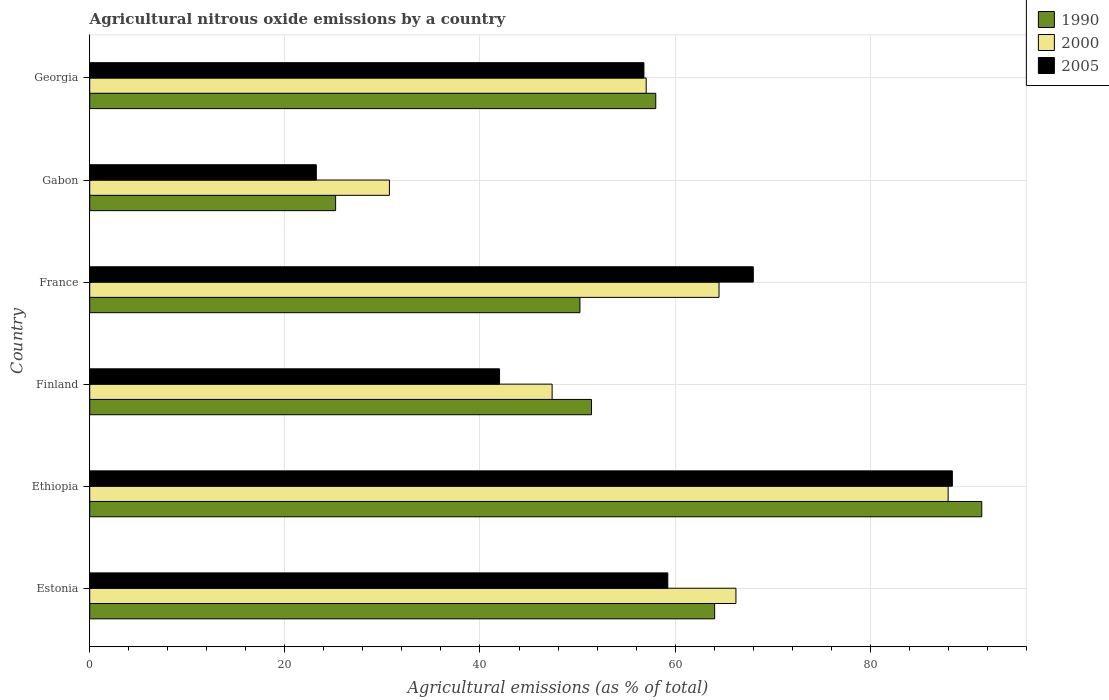How many different coloured bars are there?
Offer a terse response. 3. Are the number of bars per tick equal to the number of legend labels?
Provide a succinct answer. Yes. Are the number of bars on each tick of the Y-axis equal?
Ensure brevity in your answer.  Yes. What is the label of the 6th group of bars from the top?
Keep it short and to the point. Estonia. What is the amount of agricultural nitrous oxide emitted in 1990 in Georgia?
Offer a terse response. 58.02. Across all countries, what is the maximum amount of agricultural nitrous oxide emitted in 2000?
Your answer should be compact. 87.99. Across all countries, what is the minimum amount of agricultural nitrous oxide emitted in 2000?
Your answer should be compact. 30.72. In which country was the amount of agricultural nitrous oxide emitted in 1990 maximum?
Make the answer very short. Ethiopia. In which country was the amount of agricultural nitrous oxide emitted in 1990 minimum?
Provide a succinct answer. Gabon. What is the total amount of agricultural nitrous oxide emitted in 2000 in the graph?
Provide a short and direct response. 353.88. What is the difference between the amount of agricultural nitrous oxide emitted in 1990 in Estonia and that in Gabon?
Offer a terse response. 38.85. What is the difference between the amount of agricultural nitrous oxide emitted in 2005 in Finland and the amount of agricultural nitrous oxide emitted in 2000 in France?
Give a very brief answer. -22.5. What is the average amount of agricultural nitrous oxide emitted in 1990 per country?
Ensure brevity in your answer.  56.73. What is the difference between the amount of agricultural nitrous oxide emitted in 1990 and amount of agricultural nitrous oxide emitted in 2005 in Georgia?
Keep it short and to the point. 1.21. In how many countries, is the amount of agricultural nitrous oxide emitted in 1990 greater than 60 %?
Make the answer very short. 2. What is the ratio of the amount of agricultural nitrous oxide emitted in 2000 in Finland to that in France?
Ensure brevity in your answer.  0.73. Is the amount of agricultural nitrous oxide emitted in 1990 in Gabon less than that in Georgia?
Your answer should be compact. Yes. What is the difference between the highest and the second highest amount of agricultural nitrous oxide emitted in 1990?
Provide a short and direct response. 27.38. What is the difference between the highest and the lowest amount of agricultural nitrous oxide emitted in 2005?
Ensure brevity in your answer.  65.19. In how many countries, is the amount of agricultural nitrous oxide emitted in 1990 greater than the average amount of agricultural nitrous oxide emitted in 1990 taken over all countries?
Offer a terse response. 3. What does the 1st bar from the bottom in France represents?
Ensure brevity in your answer.  1990. How many countries are there in the graph?
Provide a short and direct response. 6. Are the values on the major ticks of X-axis written in scientific E-notation?
Your response must be concise. No. Does the graph contain grids?
Make the answer very short. Yes. How many legend labels are there?
Give a very brief answer. 3. What is the title of the graph?
Your answer should be very brief. Agricultural nitrous oxide emissions by a country. What is the label or title of the X-axis?
Offer a very short reply. Agricultural emissions (as % of total). What is the Agricultural emissions (as % of total) of 1990 in Estonia?
Your response must be concise. 64.06. What is the Agricultural emissions (as % of total) in 2000 in Estonia?
Your response must be concise. 66.24. What is the Agricultural emissions (as % of total) in 2005 in Estonia?
Keep it short and to the point. 59.25. What is the Agricultural emissions (as % of total) in 1990 in Ethiopia?
Keep it short and to the point. 91.43. What is the Agricultural emissions (as % of total) of 2000 in Ethiopia?
Your answer should be very brief. 87.99. What is the Agricultural emissions (as % of total) in 2005 in Ethiopia?
Your response must be concise. 88.42. What is the Agricultural emissions (as % of total) of 1990 in Finland?
Offer a very short reply. 51.43. What is the Agricultural emissions (as % of total) in 2000 in Finland?
Your answer should be very brief. 47.4. What is the Agricultural emissions (as % of total) of 2005 in Finland?
Your answer should be very brief. 42.01. What is the Agricultural emissions (as % of total) in 1990 in France?
Provide a succinct answer. 50.25. What is the Agricultural emissions (as % of total) of 2000 in France?
Offer a terse response. 64.5. What is the Agricultural emissions (as % of total) in 2005 in France?
Provide a short and direct response. 68.02. What is the Agricultural emissions (as % of total) in 1990 in Gabon?
Provide a succinct answer. 25.2. What is the Agricultural emissions (as % of total) of 2000 in Gabon?
Your answer should be very brief. 30.72. What is the Agricultural emissions (as % of total) in 2005 in Gabon?
Offer a very short reply. 23.22. What is the Agricultural emissions (as % of total) of 1990 in Georgia?
Make the answer very short. 58.02. What is the Agricultural emissions (as % of total) of 2000 in Georgia?
Your answer should be very brief. 57.04. What is the Agricultural emissions (as % of total) in 2005 in Georgia?
Ensure brevity in your answer.  56.81. Across all countries, what is the maximum Agricultural emissions (as % of total) in 1990?
Provide a short and direct response. 91.43. Across all countries, what is the maximum Agricultural emissions (as % of total) in 2000?
Your response must be concise. 87.99. Across all countries, what is the maximum Agricultural emissions (as % of total) of 2005?
Your response must be concise. 88.42. Across all countries, what is the minimum Agricultural emissions (as % of total) of 1990?
Offer a very short reply. 25.2. Across all countries, what is the minimum Agricultural emissions (as % of total) of 2000?
Ensure brevity in your answer.  30.72. Across all countries, what is the minimum Agricultural emissions (as % of total) in 2005?
Keep it short and to the point. 23.22. What is the total Agricultural emissions (as % of total) of 1990 in the graph?
Provide a succinct answer. 340.39. What is the total Agricultural emissions (as % of total) of 2000 in the graph?
Provide a short and direct response. 353.88. What is the total Agricultural emissions (as % of total) of 2005 in the graph?
Your answer should be compact. 337.72. What is the difference between the Agricultural emissions (as % of total) in 1990 in Estonia and that in Ethiopia?
Ensure brevity in your answer.  -27.38. What is the difference between the Agricultural emissions (as % of total) of 2000 in Estonia and that in Ethiopia?
Ensure brevity in your answer.  -21.75. What is the difference between the Agricultural emissions (as % of total) of 2005 in Estonia and that in Ethiopia?
Your response must be concise. -29.17. What is the difference between the Agricultural emissions (as % of total) of 1990 in Estonia and that in Finland?
Provide a short and direct response. 12.62. What is the difference between the Agricultural emissions (as % of total) of 2000 in Estonia and that in Finland?
Provide a short and direct response. 18.84. What is the difference between the Agricultural emissions (as % of total) of 2005 in Estonia and that in Finland?
Provide a short and direct response. 17.25. What is the difference between the Agricultural emissions (as % of total) of 1990 in Estonia and that in France?
Ensure brevity in your answer.  13.81. What is the difference between the Agricultural emissions (as % of total) of 2000 in Estonia and that in France?
Your answer should be compact. 1.73. What is the difference between the Agricultural emissions (as % of total) in 2005 in Estonia and that in France?
Offer a very short reply. -8.76. What is the difference between the Agricultural emissions (as % of total) of 1990 in Estonia and that in Gabon?
Your answer should be compact. 38.85. What is the difference between the Agricultural emissions (as % of total) in 2000 in Estonia and that in Gabon?
Offer a very short reply. 35.52. What is the difference between the Agricultural emissions (as % of total) of 2005 in Estonia and that in Gabon?
Offer a very short reply. 36.03. What is the difference between the Agricultural emissions (as % of total) of 1990 in Estonia and that in Georgia?
Ensure brevity in your answer.  6.04. What is the difference between the Agricultural emissions (as % of total) of 2000 in Estonia and that in Georgia?
Your response must be concise. 9.2. What is the difference between the Agricultural emissions (as % of total) in 2005 in Estonia and that in Georgia?
Your response must be concise. 2.45. What is the difference between the Agricultural emissions (as % of total) in 1990 in Ethiopia and that in Finland?
Provide a succinct answer. 40. What is the difference between the Agricultural emissions (as % of total) in 2000 in Ethiopia and that in Finland?
Give a very brief answer. 40.59. What is the difference between the Agricultural emissions (as % of total) in 2005 in Ethiopia and that in Finland?
Your response must be concise. 46.41. What is the difference between the Agricultural emissions (as % of total) in 1990 in Ethiopia and that in France?
Make the answer very short. 41.19. What is the difference between the Agricultural emissions (as % of total) of 2000 in Ethiopia and that in France?
Your response must be concise. 23.48. What is the difference between the Agricultural emissions (as % of total) in 2005 in Ethiopia and that in France?
Your answer should be compact. 20.4. What is the difference between the Agricultural emissions (as % of total) of 1990 in Ethiopia and that in Gabon?
Your answer should be compact. 66.23. What is the difference between the Agricultural emissions (as % of total) of 2000 in Ethiopia and that in Gabon?
Provide a succinct answer. 57.27. What is the difference between the Agricultural emissions (as % of total) of 2005 in Ethiopia and that in Gabon?
Offer a terse response. 65.19. What is the difference between the Agricultural emissions (as % of total) in 1990 in Ethiopia and that in Georgia?
Your response must be concise. 33.41. What is the difference between the Agricultural emissions (as % of total) of 2000 in Ethiopia and that in Georgia?
Offer a terse response. 30.95. What is the difference between the Agricultural emissions (as % of total) of 2005 in Ethiopia and that in Georgia?
Offer a terse response. 31.61. What is the difference between the Agricultural emissions (as % of total) of 1990 in Finland and that in France?
Offer a very short reply. 1.19. What is the difference between the Agricultural emissions (as % of total) of 2000 in Finland and that in France?
Offer a very short reply. -17.11. What is the difference between the Agricultural emissions (as % of total) of 2005 in Finland and that in France?
Your response must be concise. -26.01. What is the difference between the Agricultural emissions (as % of total) of 1990 in Finland and that in Gabon?
Provide a short and direct response. 26.23. What is the difference between the Agricultural emissions (as % of total) in 2000 in Finland and that in Gabon?
Make the answer very short. 16.68. What is the difference between the Agricultural emissions (as % of total) in 2005 in Finland and that in Gabon?
Your answer should be compact. 18.78. What is the difference between the Agricultural emissions (as % of total) of 1990 in Finland and that in Georgia?
Your response must be concise. -6.59. What is the difference between the Agricultural emissions (as % of total) in 2000 in Finland and that in Georgia?
Your response must be concise. -9.64. What is the difference between the Agricultural emissions (as % of total) in 2005 in Finland and that in Georgia?
Offer a terse response. -14.8. What is the difference between the Agricultural emissions (as % of total) of 1990 in France and that in Gabon?
Provide a short and direct response. 25.04. What is the difference between the Agricultural emissions (as % of total) in 2000 in France and that in Gabon?
Give a very brief answer. 33.79. What is the difference between the Agricultural emissions (as % of total) of 2005 in France and that in Gabon?
Provide a short and direct response. 44.79. What is the difference between the Agricultural emissions (as % of total) of 1990 in France and that in Georgia?
Give a very brief answer. -7.77. What is the difference between the Agricultural emissions (as % of total) of 2000 in France and that in Georgia?
Provide a succinct answer. 7.47. What is the difference between the Agricultural emissions (as % of total) of 2005 in France and that in Georgia?
Your answer should be compact. 11.21. What is the difference between the Agricultural emissions (as % of total) in 1990 in Gabon and that in Georgia?
Keep it short and to the point. -32.82. What is the difference between the Agricultural emissions (as % of total) in 2000 in Gabon and that in Georgia?
Your answer should be very brief. -26.32. What is the difference between the Agricultural emissions (as % of total) of 2005 in Gabon and that in Georgia?
Make the answer very short. -33.58. What is the difference between the Agricultural emissions (as % of total) in 1990 in Estonia and the Agricultural emissions (as % of total) in 2000 in Ethiopia?
Ensure brevity in your answer.  -23.93. What is the difference between the Agricultural emissions (as % of total) in 1990 in Estonia and the Agricultural emissions (as % of total) in 2005 in Ethiopia?
Provide a short and direct response. -24.36. What is the difference between the Agricultural emissions (as % of total) in 2000 in Estonia and the Agricultural emissions (as % of total) in 2005 in Ethiopia?
Make the answer very short. -22.18. What is the difference between the Agricultural emissions (as % of total) of 1990 in Estonia and the Agricultural emissions (as % of total) of 2000 in Finland?
Provide a succinct answer. 16.66. What is the difference between the Agricultural emissions (as % of total) of 1990 in Estonia and the Agricultural emissions (as % of total) of 2005 in Finland?
Make the answer very short. 22.05. What is the difference between the Agricultural emissions (as % of total) of 2000 in Estonia and the Agricultural emissions (as % of total) of 2005 in Finland?
Offer a terse response. 24.23. What is the difference between the Agricultural emissions (as % of total) of 1990 in Estonia and the Agricultural emissions (as % of total) of 2000 in France?
Your answer should be compact. -0.45. What is the difference between the Agricultural emissions (as % of total) of 1990 in Estonia and the Agricultural emissions (as % of total) of 2005 in France?
Give a very brief answer. -3.96. What is the difference between the Agricultural emissions (as % of total) in 2000 in Estonia and the Agricultural emissions (as % of total) in 2005 in France?
Ensure brevity in your answer.  -1.78. What is the difference between the Agricultural emissions (as % of total) in 1990 in Estonia and the Agricultural emissions (as % of total) in 2000 in Gabon?
Make the answer very short. 33.34. What is the difference between the Agricultural emissions (as % of total) of 1990 in Estonia and the Agricultural emissions (as % of total) of 2005 in Gabon?
Provide a short and direct response. 40.83. What is the difference between the Agricultural emissions (as % of total) in 2000 in Estonia and the Agricultural emissions (as % of total) in 2005 in Gabon?
Provide a succinct answer. 43.01. What is the difference between the Agricultural emissions (as % of total) of 1990 in Estonia and the Agricultural emissions (as % of total) of 2000 in Georgia?
Keep it short and to the point. 7.02. What is the difference between the Agricultural emissions (as % of total) of 1990 in Estonia and the Agricultural emissions (as % of total) of 2005 in Georgia?
Provide a succinct answer. 7.25. What is the difference between the Agricultural emissions (as % of total) of 2000 in Estonia and the Agricultural emissions (as % of total) of 2005 in Georgia?
Provide a succinct answer. 9.43. What is the difference between the Agricultural emissions (as % of total) in 1990 in Ethiopia and the Agricultural emissions (as % of total) in 2000 in Finland?
Your answer should be very brief. 44.04. What is the difference between the Agricultural emissions (as % of total) of 1990 in Ethiopia and the Agricultural emissions (as % of total) of 2005 in Finland?
Offer a very short reply. 49.43. What is the difference between the Agricultural emissions (as % of total) of 2000 in Ethiopia and the Agricultural emissions (as % of total) of 2005 in Finland?
Your answer should be compact. 45.98. What is the difference between the Agricultural emissions (as % of total) of 1990 in Ethiopia and the Agricultural emissions (as % of total) of 2000 in France?
Offer a terse response. 26.93. What is the difference between the Agricultural emissions (as % of total) of 1990 in Ethiopia and the Agricultural emissions (as % of total) of 2005 in France?
Your response must be concise. 23.42. What is the difference between the Agricultural emissions (as % of total) in 2000 in Ethiopia and the Agricultural emissions (as % of total) in 2005 in France?
Keep it short and to the point. 19.97. What is the difference between the Agricultural emissions (as % of total) of 1990 in Ethiopia and the Agricultural emissions (as % of total) of 2000 in Gabon?
Ensure brevity in your answer.  60.72. What is the difference between the Agricultural emissions (as % of total) of 1990 in Ethiopia and the Agricultural emissions (as % of total) of 2005 in Gabon?
Make the answer very short. 68.21. What is the difference between the Agricultural emissions (as % of total) of 2000 in Ethiopia and the Agricultural emissions (as % of total) of 2005 in Gabon?
Keep it short and to the point. 64.76. What is the difference between the Agricultural emissions (as % of total) in 1990 in Ethiopia and the Agricultural emissions (as % of total) in 2000 in Georgia?
Give a very brief answer. 34.4. What is the difference between the Agricultural emissions (as % of total) of 1990 in Ethiopia and the Agricultural emissions (as % of total) of 2005 in Georgia?
Your response must be concise. 34.63. What is the difference between the Agricultural emissions (as % of total) of 2000 in Ethiopia and the Agricultural emissions (as % of total) of 2005 in Georgia?
Make the answer very short. 31.18. What is the difference between the Agricultural emissions (as % of total) in 1990 in Finland and the Agricultural emissions (as % of total) in 2000 in France?
Provide a succinct answer. -13.07. What is the difference between the Agricultural emissions (as % of total) of 1990 in Finland and the Agricultural emissions (as % of total) of 2005 in France?
Provide a succinct answer. -16.58. What is the difference between the Agricultural emissions (as % of total) in 2000 in Finland and the Agricultural emissions (as % of total) in 2005 in France?
Ensure brevity in your answer.  -20.62. What is the difference between the Agricultural emissions (as % of total) in 1990 in Finland and the Agricultural emissions (as % of total) in 2000 in Gabon?
Ensure brevity in your answer.  20.72. What is the difference between the Agricultural emissions (as % of total) in 1990 in Finland and the Agricultural emissions (as % of total) in 2005 in Gabon?
Your response must be concise. 28.21. What is the difference between the Agricultural emissions (as % of total) of 2000 in Finland and the Agricultural emissions (as % of total) of 2005 in Gabon?
Ensure brevity in your answer.  24.17. What is the difference between the Agricultural emissions (as % of total) in 1990 in Finland and the Agricultural emissions (as % of total) in 2000 in Georgia?
Your answer should be very brief. -5.6. What is the difference between the Agricultural emissions (as % of total) in 1990 in Finland and the Agricultural emissions (as % of total) in 2005 in Georgia?
Make the answer very short. -5.37. What is the difference between the Agricultural emissions (as % of total) in 2000 in Finland and the Agricultural emissions (as % of total) in 2005 in Georgia?
Offer a terse response. -9.41. What is the difference between the Agricultural emissions (as % of total) in 1990 in France and the Agricultural emissions (as % of total) in 2000 in Gabon?
Your answer should be very brief. 19.53. What is the difference between the Agricultural emissions (as % of total) in 1990 in France and the Agricultural emissions (as % of total) in 2005 in Gabon?
Offer a terse response. 27.02. What is the difference between the Agricultural emissions (as % of total) of 2000 in France and the Agricultural emissions (as % of total) of 2005 in Gabon?
Make the answer very short. 41.28. What is the difference between the Agricultural emissions (as % of total) in 1990 in France and the Agricultural emissions (as % of total) in 2000 in Georgia?
Provide a short and direct response. -6.79. What is the difference between the Agricultural emissions (as % of total) in 1990 in France and the Agricultural emissions (as % of total) in 2005 in Georgia?
Provide a short and direct response. -6.56. What is the difference between the Agricultural emissions (as % of total) of 2000 in France and the Agricultural emissions (as % of total) of 2005 in Georgia?
Make the answer very short. 7.7. What is the difference between the Agricultural emissions (as % of total) of 1990 in Gabon and the Agricultural emissions (as % of total) of 2000 in Georgia?
Your answer should be very brief. -31.83. What is the difference between the Agricultural emissions (as % of total) in 1990 in Gabon and the Agricultural emissions (as % of total) in 2005 in Georgia?
Offer a terse response. -31.6. What is the difference between the Agricultural emissions (as % of total) of 2000 in Gabon and the Agricultural emissions (as % of total) of 2005 in Georgia?
Offer a terse response. -26.09. What is the average Agricultural emissions (as % of total) in 1990 per country?
Provide a short and direct response. 56.73. What is the average Agricultural emissions (as % of total) in 2000 per country?
Give a very brief answer. 58.98. What is the average Agricultural emissions (as % of total) of 2005 per country?
Your answer should be very brief. 56.29. What is the difference between the Agricultural emissions (as % of total) in 1990 and Agricultural emissions (as % of total) in 2000 in Estonia?
Ensure brevity in your answer.  -2.18. What is the difference between the Agricultural emissions (as % of total) of 1990 and Agricultural emissions (as % of total) of 2005 in Estonia?
Offer a very short reply. 4.8. What is the difference between the Agricultural emissions (as % of total) of 2000 and Agricultural emissions (as % of total) of 2005 in Estonia?
Provide a short and direct response. 6.98. What is the difference between the Agricultural emissions (as % of total) in 1990 and Agricultural emissions (as % of total) in 2000 in Ethiopia?
Your answer should be compact. 3.45. What is the difference between the Agricultural emissions (as % of total) in 1990 and Agricultural emissions (as % of total) in 2005 in Ethiopia?
Provide a succinct answer. 3.02. What is the difference between the Agricultural emissions (as % of total) of 2000 and Agricultural emissions (as % of total) of 2005 in Ethiopia?
Keep it short and to the point. -0.43. What is the difference between the Agricultural emissions (as % of total) of 1990 and Agricultural emissions (as % of total) of 2000 in Finland?
Your response must be concise. 4.04. What is the difference between the Agricultural emissions (as % of total) of 1990 and Agricultural emissions (as % of total) of 2005 in Finland?
Provide a succinct answer. 9.43. What is the difference between the Agricultural emissions (as % of total) of 2000 and Agricultural emissions (as % of total) of 2005 in Finland?
Provide a short and direct response. 5.39. What is the difference between the Agricultural emissions (as % of total) of 1990 and Agricultural emissions (as % of total) of 2000 in France?
Your response must be concise. -14.26. What is the difference between the Agricultural emissions (as % of total) of 1990 and Agricultural emissions (as % of total) of 2005 in France?
Your answer should be compact. -17.77. What is the difference between the Agricultural emissions (as % of total) of 2000 and Agricultural emissions (as % of total) of 2005 in France?
Make the answer very short. -3.51. What is the difference between the Agricultural emissions (as % of total) in 1990 and Agricultural emissions (as % of total) in 2000 in Gabon?
Give a very brief answer. -5.51. What is the difference between the Agricultural emissions (as % of total) in 1990 and Agricultural emissions (as % of total) in 2005 in Gabon?
Provide a succinct answer. 1.98. What is the difference between the Agricultural emissions (as % of total) in 2000 and Agricultural emissions (as % of total) in 2005 in Gabon?
Provide a short and direct response. 7.49. What is the difference between the Agricultural emissions (as % of total) in 1990 and Agricultural emissions (as % of total) in 2000 in Georgia?
Keep it short and to the point. 0.98. What is the difference between the Agricultural emissions (as % of total) in 1990 and Agricultural emissions (as % of total) in 2005 in Georgia?
Make the answer very short. 1.21. What is the difference between the Agricultural emissions (as % of total) in 2000 and Agricultural emissions (as % of total) in 2005 in Georgia?
Your response must be concise. 0.23. What is the ratio of the Agricultural emissions (as % of total) of 1990 in Estonia to that in Ethiopia?
Make the answer very short. 0.7. What is the ratio of the Agricultural emissions (as % of total) in 2000 in Estonia to that in Ethiopia?
Keep it short and to the point. 0.75. What is the ratio of the Agricultural emissions (as % of total) of 2005 in Estonia to that in Ethiopia?
Keep it short and to the point. 0.67. What is the ratio of the Agricultural emissions (as % of total) of 1990 in Estonia to that in Finland?
Your answer should be very brief. 1.25. What is the ratio of the Agricultural emissions (as % of total) of 2000 in Estonia to that in Finland?
Keep it short and to the point. 1.4. What is the ratio of the Agricultural emissions (as % of total) in 2005 in Estonia to that in Finland?
Give a very brief answer. 1.41. What is the ratio of the Agricultural emissions (as % of total) in 1990 in Estonia to that in France?
Your response must be concise. 1.27. What is the ratio of the Agricultural emissions (as % of total) of 2000 in Estonia to that in France?
Offer a terse response. 1.03. What is the ratio of the Agricultural emissions (as % of total) in 2005 in Estonia to that in France?
Give a very brief answer. 0.87. What is the ratio of the Agricultural emissions (as % of total) in 1990 in Estonia to that in Gabon?
Make the answer very short. 2.54. What is the ratio of the Agricultural emissions (as % of total) in 2000 in Estonia to that in Gabon?
Make the answer very short. 2.16. What is the ratio of the Agricultural emissions (as % of total) of 2005 in Estonia to that in Gabon?
Ensure brevity in your answer.  2.55. What is the ratio of the Agricultural emissions (as % of total) of 1990 in Estonia to that in Georgia?
Offer a terse response. 1.1. What is the ratio of the Agricultural emissions (as % of total) of 2000 in Estonia to that in Georgia?
Make the answer very short. 1.16. What is the ratio of the Agricultural emissions (as % of total) of 2005 in Estonia to that in Georgia?
Make the answer very short. 1.04. What is the ratio of the Agricultural emissions (as % of total) of 1990 in Ethiopia to that in Finland?
Offer a very short reply. 1.78. What is the ratio of the Agricultural emissions (as % of total) of 2000 in Ethiopia to that in Finland?
Your answer should be compact. 1.86. What is the ratio of the Agricultural emissions (as % of total) in 2005 in Ethiopia to that in Finland?
Give a very brief answer. 2.1. What is the ratio of the Agricultural emissions (as % of total) in 1990 in Ethiopia to that in France?
Give a very brief answer. 1.82. What is the ratio of the Agricultural emissions (as % of total) in 2000 in Ethiopia to that in France?
Your response must be concise. 1.36. What is the ratio of the Agricultural emissions (as % of total) of 2005 in Ethiopia to that in France?
Ensure brevity in your answer.  1.3. What is the ratio of the Agricultural emissions (as % of total) of 1990 in Ethiopia to that in Gabon?
Your response must be concise. 3.63. What is the ratio of the Agricultural emissions (as % of total) of 2000 in Ethiopia to that in Gabon?
Your response must be concise. 2.86. What is the ratio of the Agricultural emissions (as % of total) in 2005 in Ethiopia to that in Gabon?
Provide a short and direct response. 3.81. What is the ratio of the Agricultural emissions (as % of total) in 1990 in Ethiopia to that in Georgia?
Your answer should be compact. 1.58. What is the ratio of the Agricultural emissions (as % of total) of 2000 in Ethiopia to that in Georgia?
Provide a short and direct response. 1.54. What is the ratio of the Agricultural emissions (as % of total) of 2005 in Ethiopia to that in Georgia?
Offer a terse response. 1.56. What is the ratio of the Agricultural emissions (as % of total) of 1990 in Finland to that in France?
Your answer should be compact. 1.02. What is the ratio of the Agricultural emissions (as % of total) of 2000 in Finland to that in France?
Give a very brief answer. 0.73. What is the ratio of the Agricultural emissions (as % of total) of 2005 in Finland to that in France?
Keep it short and to the point. 0.62. What is the ratio of the Agricultural emissions (as % of total) in 1990 in Finland to that in Gabon?
Keep it short and to the point. 2.04. What is the ratio of the Agricultural emissions (as % of total) in 2000 in Finland to that in Gabon?
Your answer should be very brief. 1.54. What is the ratio of the Agricultural emissions (as % of total) of 2005 in Finland to that in Gabon?
Give a very brief answer. 1.81. What is the ratio of the Agricultural emissions (as % of total) of 1990 in Finland to that in Georgia?
Your response must be concise. 0.89. What is the ratio of the Agricultural emissions (as % of total) of 2000 in Finland to that in Georgia?
Offer a terse response. 0.83. What is the ratio of the Agricultural emissions (as % of total) of 2005 in Finland to that in Georgia?
Ensure brevity in your answer.  0.74. What is the ratio of the Agricultural emissions (as % of total) in 1990 in France to that in Gabon?
Your answer should be very brief. 1.99. What is the ratio of the Agricultural emissions (as % of total) of 2000 in France to that in Gabon?
Your answer should be very brief. 2.1. What is the ratio of the Agricultural emissions (as % of total) of 2005 in France to that in Gabon?
Your response must be concise. 2.93. What is the ratio of the Agricultural emissions (as % of total) in 1990 in France to that in Georgia?
Your response must be concise. 0.87. What is the ratio of the Agricultural emissions (as % of total) of 2000 in France to that in Georgia?
Offer a very short reply. 1.13. What is the ratio of the Agricultural emissions (as % of total) of 2005 in France to that in Georgia?
Keep it short and to the point. 1.2. What is the ratio of the Agricultural emissions (as % of total) of 1990 in Gabon to that in Georgia?
Your response must be concise. 0.43. What is the ratio of the Agricultural emissions (as % of total) in 2000 in Gabon to that in Georgia?
Your answer should be compact. 0.54. What is the ratio of the Agricultural emissions (as % of total) of 2005 in Gabon to that in Georgia?
Make the answer very short. 0.41. What is the difference between the highest and the second highest Agricultural emissions (as % of total) of 1990?
Keep it short and to the point. 27.38. What is the difference between the highest and the second highest Agricultural emissions (as % of total) in 2000?
Your response must be concise. 21.75. What is the difference between the highest and the second highest Agricultural emissions (as % of total) in 2005?
Your response must be concise. 20.4. What is the difference between the highest and the lowest Agricultural emissions (as % of total) of 1990?
Provide a short and direct response. 66.23. What is the difference between the highest and the lowest Agricultural emissions (as % of total) in 2000?
Your response must be concise. 57.27. What is the difference between the highest and the lowest Agricultural emissions (as % of total) in 2005?
Your answer should be compact. 65.19. 